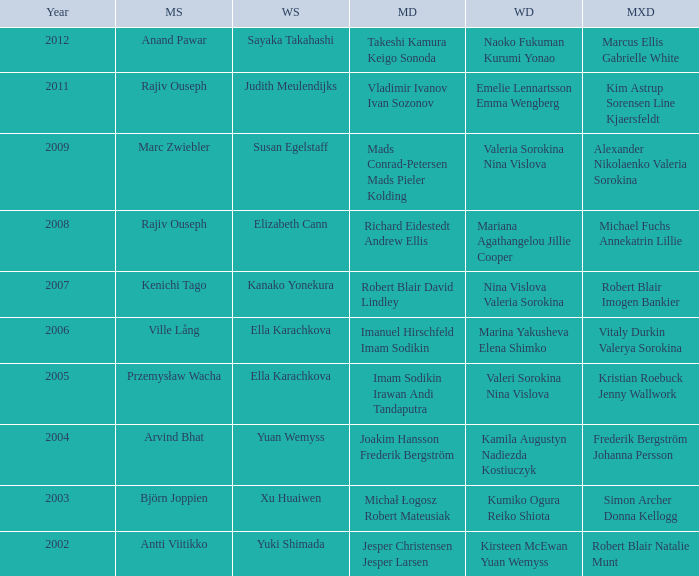What are the womens singles of naoko fukuman kurumi yonao? Sayaka Takahashi. 